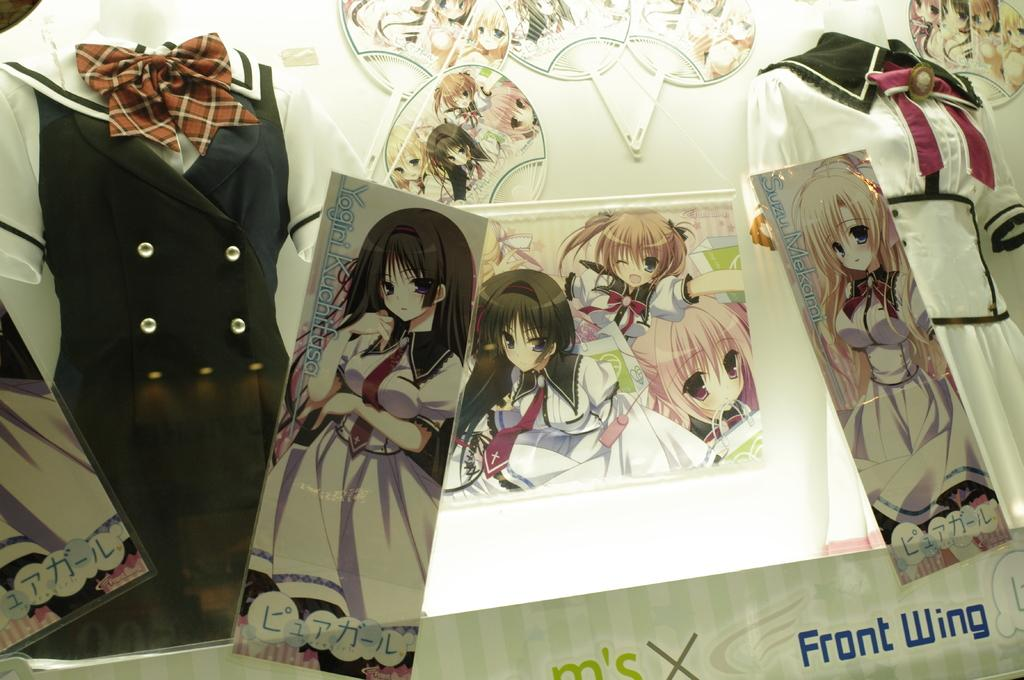What type of figures can be seen in the image? There are mannequins in the image. What are the mannequins wearing? The mannequins are wearing dresses. What decorative elements are present on the wall in the image? There are pictures of cartoons on the wall. What type of metal is being used to draw the cartoons on the wall? There is no metal being used to draw the cartoons on the wall; they are likely printed or painted images. 